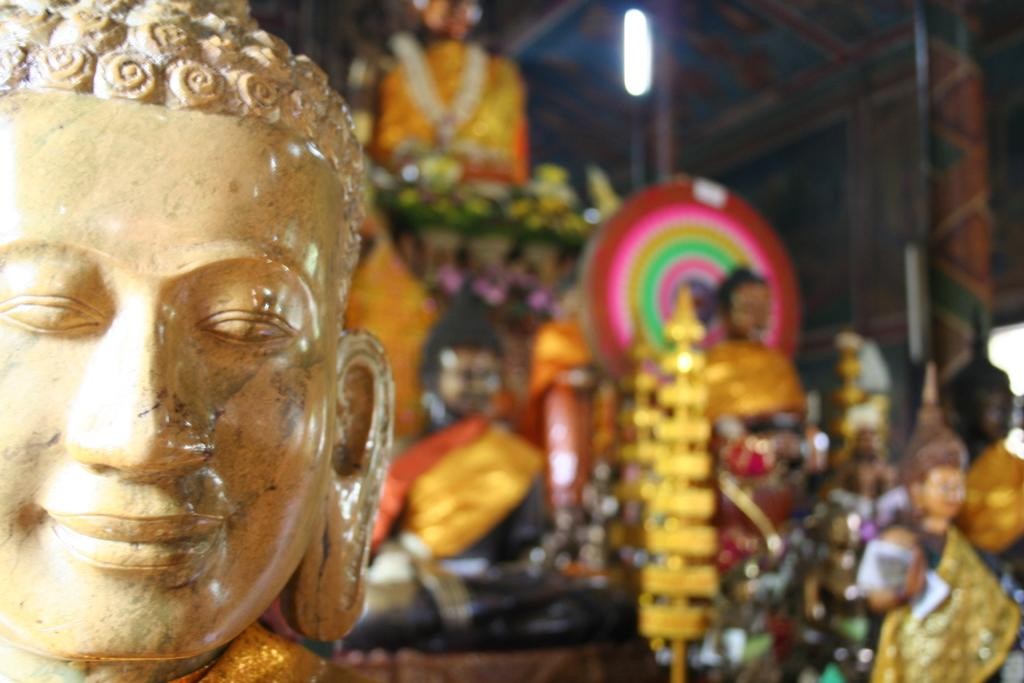What can be seen on the right side of the image? There are statues on the right side of the image. What can be seen on the left side of the image? There are statues on the left side of the image. How many statues are visible in the image? There are statues on both the right and left sides of the image, but the exact number cannot be determined without more information. What type of map is visible on the statues in the image? There is no map present on the statues in the image. What material are the statues made of in the image? The provided facts do not mention the material of the statues, so we cannot determine their composition from the image alone. 